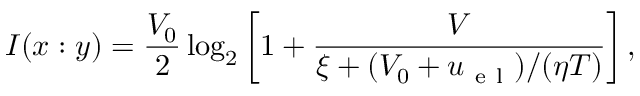<formula> <loc_0><loc_0><loc_500><loc_500>I ( x \colon y ) = \frac { V _ { 0 } } { 2 } \log _ { 2 } \left [ 1 + \frac { V } { \xi + ( V _ { 0 } + u _ { e l } ) / ( \eta T ) } \right ] ,</formula> 